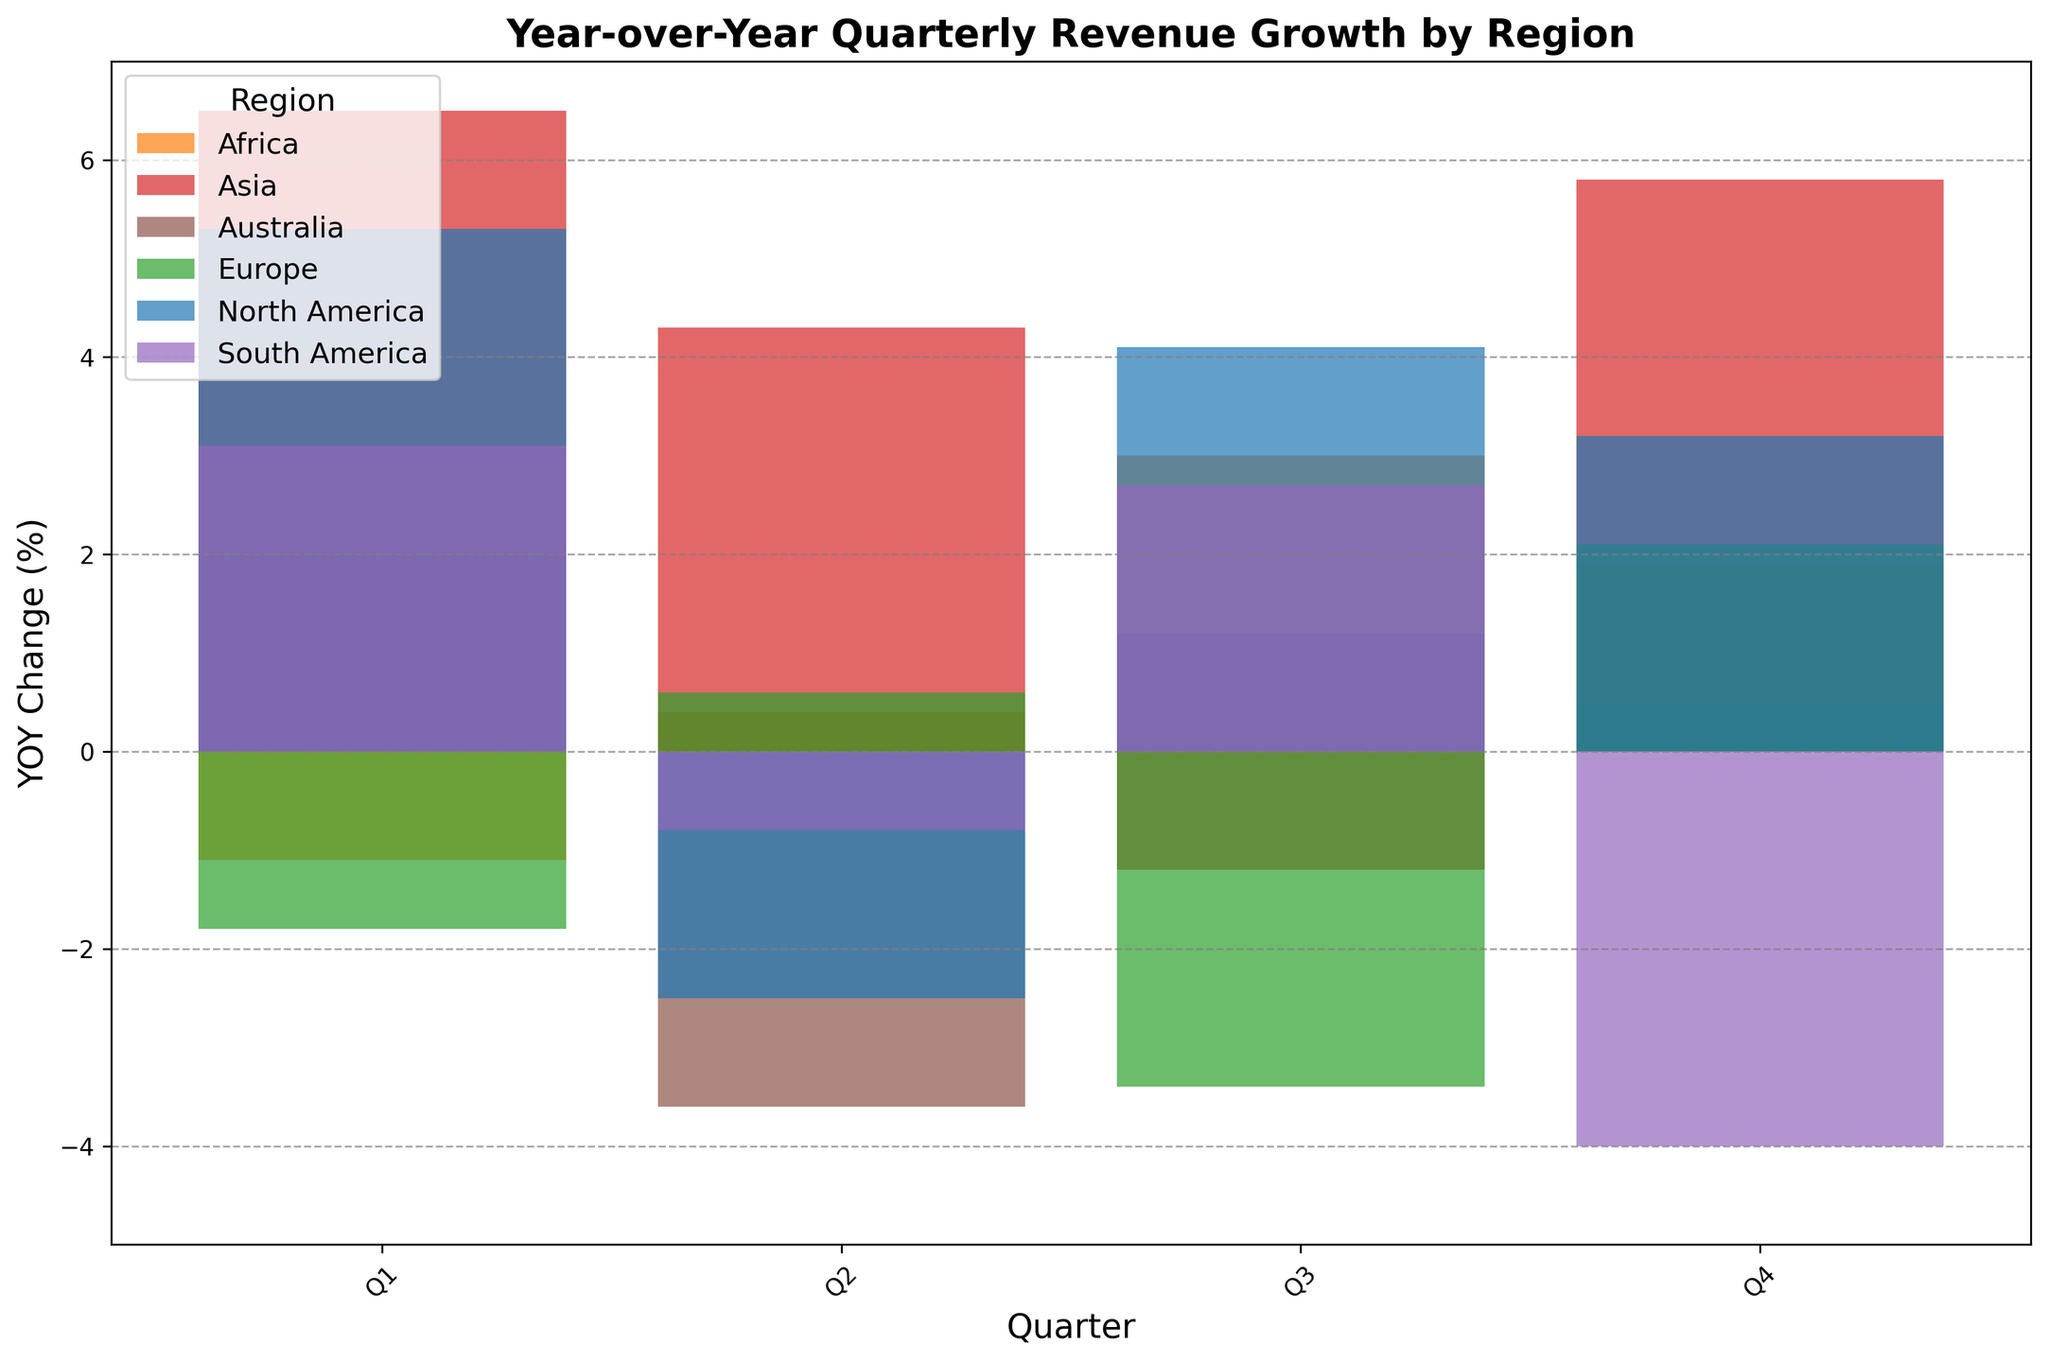What is the highest YOY change in quarterly revenue for North America? Look for the tallest bar in the 'North America' section of the chart. The highest bar represents a 5.3% YOY change in Q1.
Answer: 5.3% Which region has the most negative YOY change in any quarter? Identify the shortest (lowest) bar in the entire chart. The shortest bar represents the most negative value, which is -4.0% for South America in Q4.
Answer: South America What is the average YOY change in quarterly revenue for Europe in the first two quarters? Sum the YOY changes for Q1 and Q2 in Europe: -1.8% + 0.6% = -1.2%. Then, divide by 2: -1.2% / 2 = -0.6%.
Answer: -0.6% How does the YOY change for Asia in Q3 compare to Australia in Q2? Find the bars for Asia in Q3 and Australia in Q2. Asia in Q3 has a YOY change of -1.2%, and Australia in Q2 has -3.6%. The change for Asia (-1.2%) is less negative than Australia's (-3.6%).
Answer: Less negative Which two regions had positive YOY change in Q4? Identify the bars above the zero line for Q4. North America (3.2%), Asia (5.8%), and Europe (2.1%) have positive YOY changes in Q4. Combining the question context with positive changes: North America and Europe.
Answer: North America and Europe What is the sum of YOY changes in Q1 for all regions? Sum YOY changes for all regions in Q1: 5.3% (North America) + (-1.8%) (Europe) + 6.5% (Asia) + 3.1% (South America) + (-1.1%) (Africa) + 2.0% (Australia). The total sum is: 5.3 - 1.8 + 6.5 + 3.1 - 1.1 + 2.0 = 14.0%.
Answer: 14.0% Which region showed the most improvement in YOY change from Q2 to Q3? Compare the difference between Q2 and Q3 YOY values for each region. Calculate the improvement (or least decline): North America: 4.1 - (-2.5) = 6.6. Europe: -3.4 - 0.6 = -4. South America: 2.7 - (-0.8) = 3.5. Africa: 3.0 - 0.4 = 2.6. Australia: 1.2 - (-3.6) = 4.8. Asia: (-1.2) - 4.3 = -5.5. The highest positive difference is for North America with 6.6%.
Answer: North America 